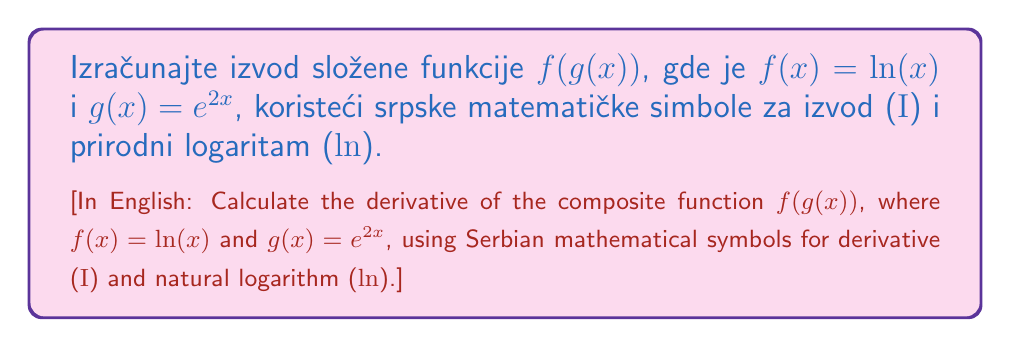Could you help me with this problem? To solve this problem, we'll use the chain rule, which in Serbian notation can be written as:

$$\mathrm{I}(f(g(x))) = \mathrm{I}f(g(x)) \cdot \mathrm{I}g(x)$$

Let's break it down step by step:

1) First, let's find $\mathrm{I}f(x)$:
   $$\mathrm{I}f(x) = \mathrm{I}(\ln(x)) = \frac{1}{x}$$

2) Now, let's find $\mathrm{I}g(x)$:
   $$\mathrm{I}g(x) = \mathrm{I}(e^{2x}) = 2e^{2x}$$

3) Applying the chain rule:
   $$\mathrm{I}(f(g(x))) = \mathrm{I}f(g(x)) \cdot \mathrm{I}g(x)$$

4) Substituting the values:
   $$\mathrm{I}(f(g(x))) = \frac{1}{g(x)} \cdot 2e^{2x}$$

5) Since $g(x) = e^{2x}$, we can substitute this:
   $$\mathrm{I}(f(g(x))) = \frac{1}{e^{2x}} \cdot 2e^{2x}$$

6) Simplifying:
   $$\mathrm{I}(f(g(x))) = \frac{2e^{2x}}{e^{2x}} = 2$$

Therefore, the derivative of the composite function is a constant, 2.
Answer: $\mathrm{I}(f(g(x))) = 2$ 